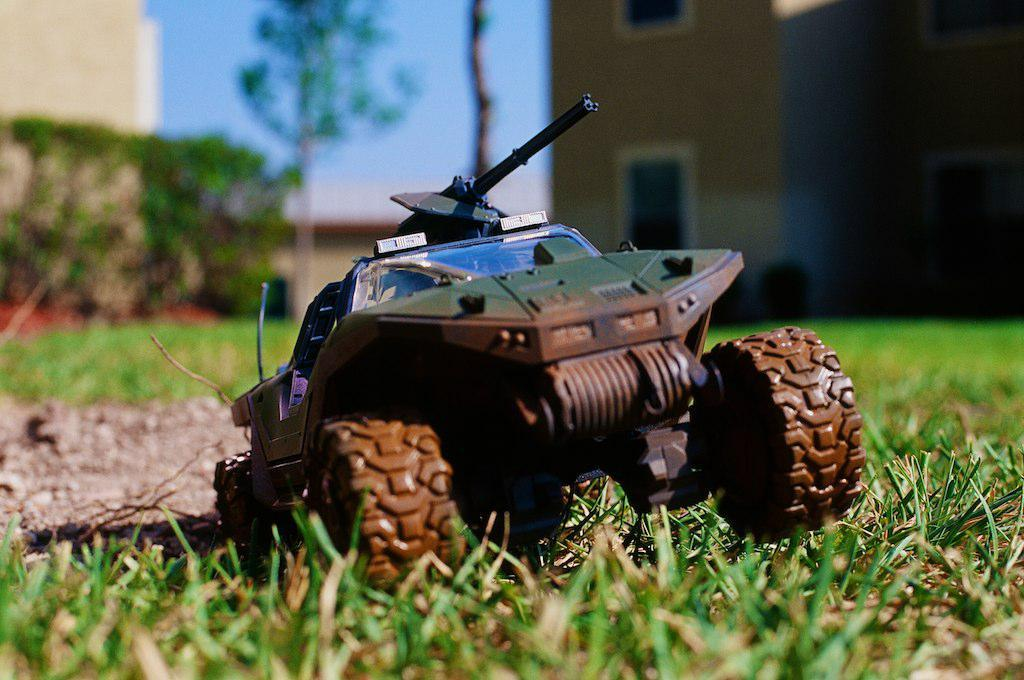What object is on the ground in the image? There is a toy on the ground. What can be seen in the background of the image? There is a building with windows and a group of trees in the background. What is visible above the trees and building in the image? The sky is visible in the background. What type of muscle is being exercised by the tree in the image? There is no muscle present in the image, as trees do not have muscles. 